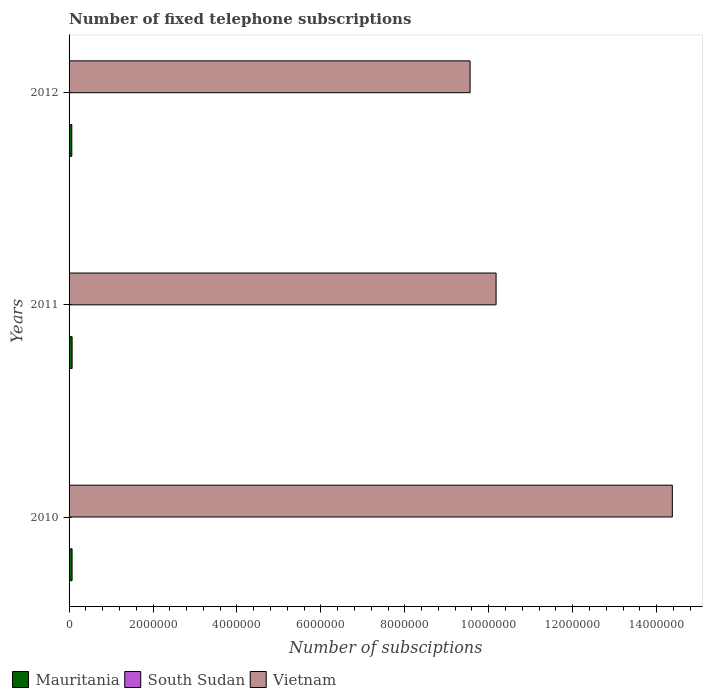How many groups of bars are there?
Offer a terse response. 3. How many bars are there on the 3rd tick from the top?
Your answer should be compact. 3. How many bars are there on the 1st tick from the bottom?
Keep it short and to the point. 3. In how many cases, is the number of bars for a given year not equal to the number of legend labels?
Ensure brevity in your answer.  0. What is the number of fixed telephone subscriptions in Mauritania in 2012?
Provide a succinct answer. 6.51e+04. Across all years, what is the maximum number of fixed telephone subscriptions in Mauritania?
Make the answer very short. 7.23e+04. Across all years, what is the minimum number of fixed telephone subscriptions in Mauritania?
Ensure brevity in your answer.  6.51e+04. In which year was the number of fixed telephone subscriptions in South Sudan maximum?
Offer a very short reply. 2010. What is the total number of fixed telephone subscriptions in South Sudan in the graph?
Keep it short and to the point. 4750. What is the difference between the number of fixed telephone subscriptions in Mauritania in 2011 and the number of fixed telephone subscriptions in Vietnam in 2012?
Your answer should be very brief. -9.48e+06. What is the average number of fixed telephone subscriptions in South Sudan per year?
Offer a very short reply. 1583.33. In the year 2011, what is the difference between the number of fixed telephone subscriptions in South Sudan and number of fixed telephone subscriptions in Mauritania?
Offer a very short reply. -7.01e+04. What is the ratio of the number of fixed telephone subscriptions in Mauritania in 2010 to that in 2011?
Ensure brevity in your answer.  0.99. What is the difference between the highest and the second highest number of fixed telephone subscriptions in Mauritania?
Offer a terse response. 722. What is the difference between the highest and the lowest number of fixed telephone subscriptions in Vietnam?
Provide a short and direct response. 4.82e+06. What does the 2nd bar from the top in 2011 represents?
Offer a very short reply. South Sudan. What does the 2nd bar from the bottom in 2010 represents?
Your response must be concise. South Sudan. Is it the case that in every year, the sum of the number of fixed telephone subscriptions in Mauritania and number of fixed telephone subscriptions in South Sudan is greater than the number of fixed telephone subscriptions in Vietnam?
Give a very brief answer. No. How many years are there in the graph?
Your response must be concise. 3. What is the difference between two consecutive major ticks on the X-axis?
Your answer should be compact. 2.00e+06. Are the values on the major ticks of X-axis written in scientific E-notation?
Offer a terse response. No. Does the graph contain grids?
Ensure brevity in your answer.  No. How many legend labels are there?
Make the answer very short. 3. How are the legend labels stacked?
Your answer should be compact. Horizontal. What is the title of the graph?
Offer a terse response. Number of fixed telephone subscriptions. What is the label or title of the X-axis?
Give a very brief answer. Number of subsciptions. What is the Number of subsciptions of Mauritania in 2010?
Provide a succinct answer. 7.16e+04. What is the Number of subsciptions in South Sudan in 2010?
Your response must be concise. 2400. What is the Number of subsciptions of Vietnam in 2010?
Keep it short and to the point. 1.44e+07. What is the Number of subsciptions of Mauritania in 2011?
Give a very brief answer. 7.23e+04. What is the Number of subsciptions in South Sudan in 2011?
Provide a succinct answer. 2200. What is the Number of subsciptions in Vietnam in 2011?
Offer a terse response. 1.02e+07. What is the Number of subsciptions in Mauritania in 2012?
Your answer should be very brief. 6.51e+04. What is the Number of subsciptions in South Sudan in 2012?
Your answer should be compact. 150. What is the Number of subsciptions of Vietnam in 2012?
Provide a short and direct response. 9.56e+06. Across all years, what is the maximum Number of subsciptions of Mauritania?
Keep it short and to the point. 7.23e+04. Across all years, what is the maximum Number of subsciptions of South Sudan?
Ensure brevity in your answer.  2400. Across all years, what is the maximum Number of subsciptions of Vietnam?
Make the answer very short. 1.44e+07. Across all years, what is the minimum Number of subsciptions in Mauritania?
Keep it short and to the point. 6.51e+04. Across all years, what is the minimum Number of subsciptions in South Sudan?
Keep it short and to the point. 150. Across all years, what is the minimum Number of subsciptions of Vietnam?
Your answer should be compact. 9.56e+06. What is the total Number of subsciptions of Mauritania in the graph?
Make the answer very short. 2.09e+05. What is the total Number of subsciptions in South Sudan in the graph?
Provide a succinct answer. 4750. What is the total Number of subsciptions of Vietnam in the graph?
Offer a very short reply. 3.41e+07. What is the difference between the Number of subsciptions in Mauritania in 2010 and that in 2011?
Your answer should be compact. -722. What is the difference between the Number of subsciptions of South Sudan in 2010 and that in 2011?
Ensure brevity in your answer.  200. What is the difference between the Number of subsciptions of Vietnam in 2010 and that in 2011?
Your response must be concise. 4.20e+06. What is the difference between the Number of subsciptions in Mauritania in 2010 and that in 2012?
Provide a short and direct response. 6503. What is the difference between the Number of subsciptions of South Sudan in 2010 and that in 2012?
Offer a very short reply. 2250. What is the difference between the Number of subsciptions of Vietnam in 2010 and that in 2012?
Your response must be concise. 4.82e+06. What is the difference between the Number of subsciptions in Mauritania in 2011 and that in 2012?
Offer a terse response. 7225. What is the difference between the Number of subsciptions of South Sudan in 2011 and that in 2012?
Offer a very short reply. 2050. What is the difference between the Number of subsciptions of Vietnam in 2011 and that in 2012?
Ensure brevity in your answer.  6.19e+05. What is the difference between the Number of subsciptions in Mauritania in 2010 and the Number of subsciptions in South Sudan in 2011?
Offer a very short reply. 6.94e+04. What is the difference between the Number of subsciptions in Mauritania in 2010 and the Number of subsciptions in Vietnam in 2011?
Offer a very short reply. -1.01e+07. What is the difference between the Number of subsciptions of South Sudan in 2010 and the Number of subsciptions of Vietnam in 2011?
Give a very brief answer. -1.02e+07. What is the difference between the Number of subsciptions of Mauritania in 2010 and the Number of subsciptions of South Sudan in 2012?
Your response must be concise. 7.14e+04. What is the difference between the Number of subsciptions of Mauritania in 2010 and the Number of subsciptions of Vietnam in 2012?
Provide a succinct answer. -9.48e+06. What is the difference between the Number of subsciptions of South Sudan in 2010 and the Number of subsciptions of Vietnam in 2012?
Provide a short and direct response. -9.55e+06. What is the difference between the Number of subsciptions in Mauritania in 2011 and the Number of subsciptions in South Sudan in 2012?
Provide a short and direct response. 7.21e+04. What is the difference between the Number of subsciptions in Mauritania in 2011 and the Number of subsciptions in Vietnam in 2012?
Offer a terse response. -9.48e+06. What is the difference between the Number of subsciptions in South Sudan in 2011 and the Number of subsciptions in Vietnam in 2012?
Make the answer very short. -9.55e+06. What is the average Number of subsciptions in Mauritania per year?
Offer a terse response. 6.96e+04. What is the average Number of subsciptions of South Sudan per year?
Make the answer very short. 1583.33. What is the average Number of subsciptions of Vietnam per year?
Provide a succinct answer. 1.14e+07. In the year 2010, what is the difference between the Number of subsciptions of Mauritania and Number of subsciptions of South Sudan?
Make the answer very short. 6.92e+04. In the year 2010, what is the difference between the Number of subsciptions of Mauritania and Number of subsciptions of Vietnam?
Keep it short and to the point. -1.43e+07. In the year 2010, what is the difference between the Number of subsciptions of South Sudan and Number of subsciptions of Vietnam?
Provide a short and direct response. -1.44e+07. In the year 2011, what is the difference between the Number of subsciptions in Mauritania and Number of subsciptions in South Sudan?
Offer a very short reply. 7.01e+04. In the year 2011, what is the difference between the Number of subsciptions in Mauritania and Number of subsciptions in Vietnam?
Ensure brevity in your answer.  -1.01e+07. In the year 2011, what is the difference between the Number of subsciptions in South Sudan and Number of subsciptions in Vietnam?
Your answer should be very brief. -1.02e+07. In the year 2012, what is the difference between the Number of subsciptions in Mauritania and Number of subsciptions in South Sudan?
Give a very brief answer. 6.49e+04. In the year 2012, what is the difference between the Number of subsciptions of Mauritania and Number of subsciptions of Vietnam?
Make the answer very short. -9.49e+06. In the year 2012, what is the difference between the Number of subsciptions of South Sudan and Number of subsciptions of Vietnam?
Provide a short and direct response. -9.56e+06. What is the ratio of the Number of subsciptions in Mauritania in 2010 to that in 2011?
Ensure brevity in your answer.  0.99. What is the ratio of the Number of subsciptions of South Sudan in 2010 to that in 2011?
Your answer should be very brief. 1.09. What is the ratio of the Number of subsciptions of Vietnam in 2010 to that in 2011?
Give a very brief answer. 1.41. What is the ratio of the Number of subsciptions in Mauritania in 2010 to that in 2012?
Offer a very short reply. 1.1. What is the ratio of the Number of subsciptions in South Sudan in 2010 to that in 2012?
Offer a terse response. 16. What is the ratio of the Number of subsciptions in Vietnam in 2010 to that in 2012?
Provide a short and direct response. 1.5. What is the ratio of the Number of subsciptions in Mauritania in 2011 to that in 2012?
Offer a very short reply. 1.11. What is the ratio of the Number of subsciptions in South Sudan in 2011 to that in 2012?
Ensure brevity in your answer.  14.67. What is the ratio of the Number of subsciptions in Vietnam in 2011 to that in 2012?
Offer a terse response. 1.06. What is the difference between the highest and the second highest Number of subsciptions of Mauritania?
Your response must be concise. 722. What is the difference between the highest and the second highest Number of subsciptions in Vietnam?
Your answer should be very brief. 4.20e+06. What is the difference between the highest and the lowest Number of subsciptions of Mauritania?
Give a very brief answer. 7225. What is the difference between the highest and the lowest Number of subsciptions in South Sudan?
Your answer should be very brief. 2250. What is the difference between the highest and the lowest Number of subsciptions in Vietnam?
Your answer should be compact. 4.82e+06. 